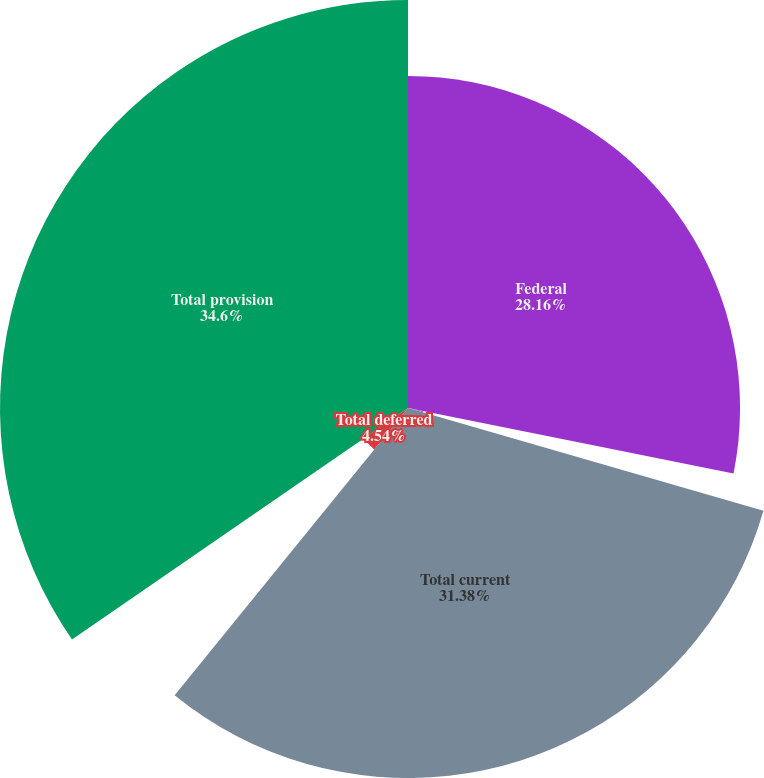<chart> <loc_0><loc_0><loc_500><loc_500><pie_chart><fcel>Federal<fcel>State<fcel>Total current<fcel>Total deferred<fcel>Total provision<nl><fcel>28.16%<fcel>1.32%<fcel>31.38%<fcel>4.54%<fcel>34.6%<nl></chart> 